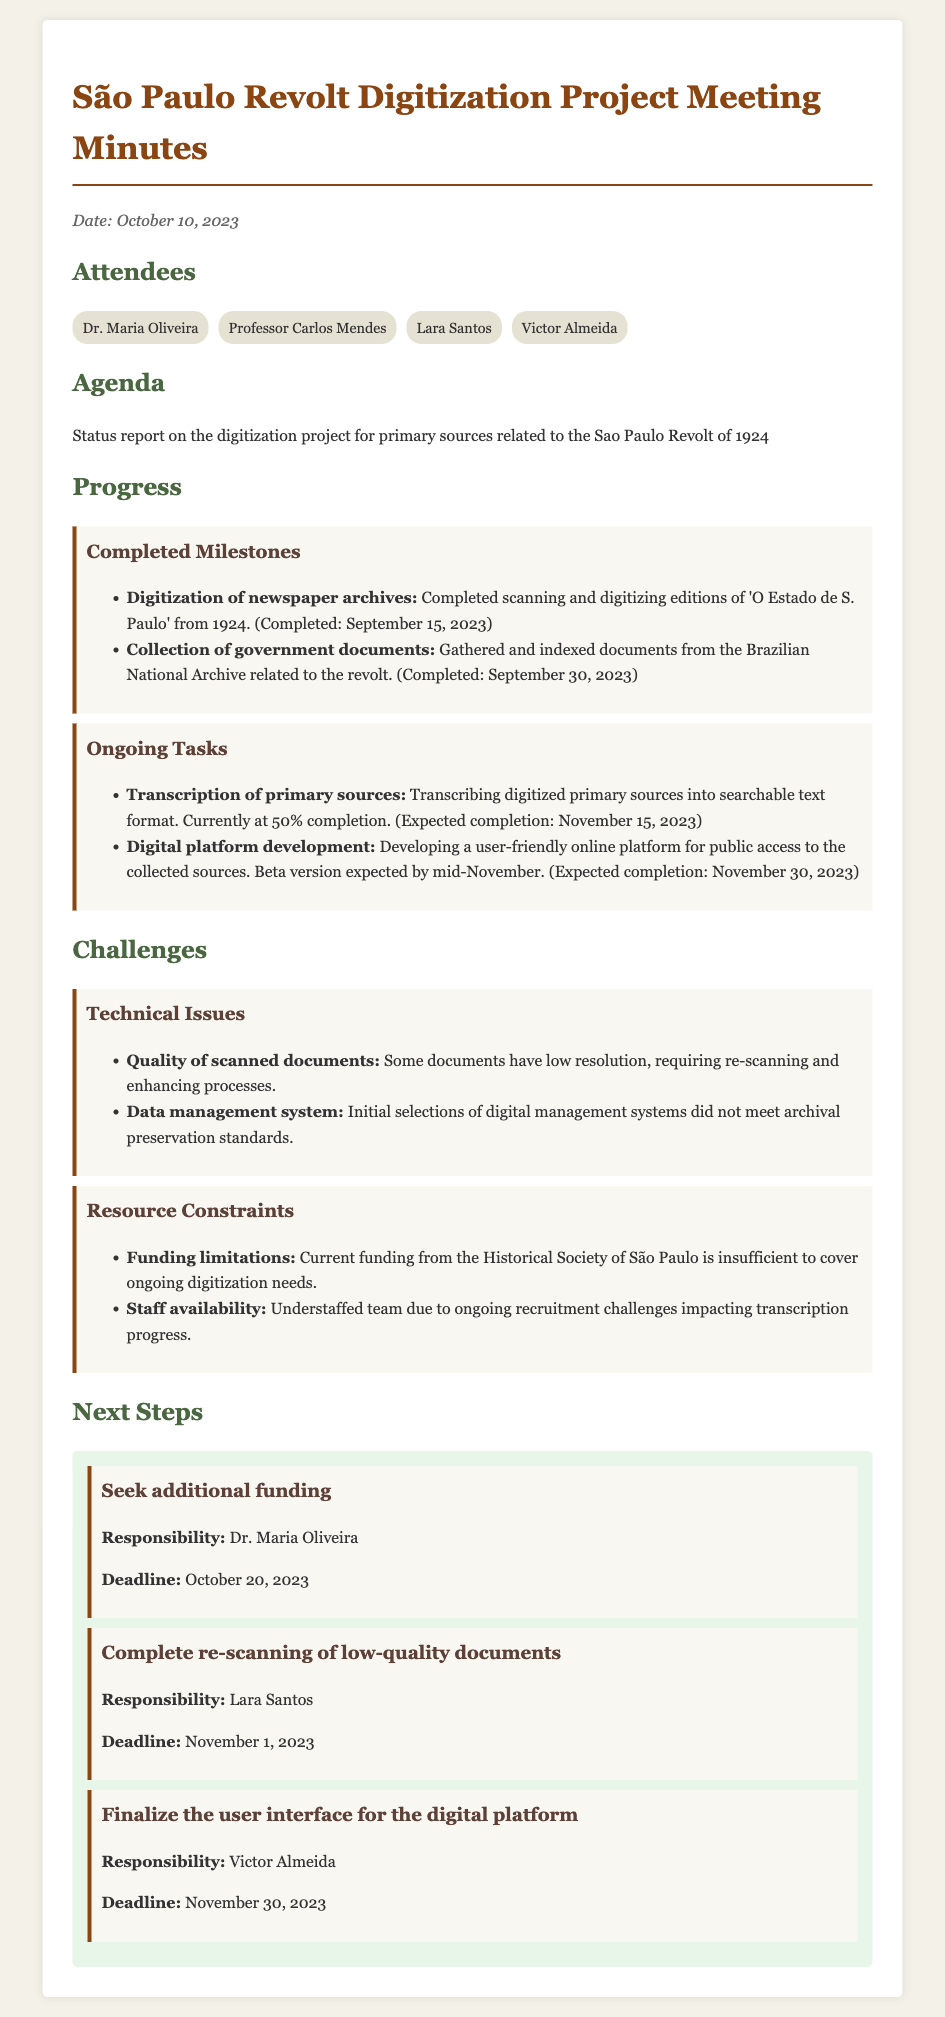What is the date of the meeting? The date of the meeting is stated at the top of the document.
Answer: October 10, 2023 Who completed the digitization of newspaper archives? The document lists attendees and details of completed tasks, indicating who was responsible.
Answer: Dr. Maria Oliveira What percentage of transcription of primary sources is currently completed? The progress section provides specific completion percentages for ongoing tasks.
Answer: 50% What is the expected completion date for the digital platform development? The ongoing tasks indicate future deadlines.
Answer: November 30, 2023 What challenge is related to staff availability? The challenges section specifies issues faced by the team.
Answer: Understaffed team What is the deadline for completing the re-scanning of low-quality documents? The next steps outline deadlines for specific actions that need to be taken.
Answer: November 1, 2023 Who is responsible for seeking additional funding? The next steps list responsibilities assigned to individuals.
Answer: Dr. Maria Oliveira What type of documents were indexed from the Brazilian National Archive? The progress section mentions the nature of documents gathered.
Answer: Government documents 